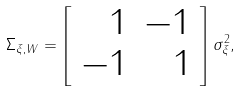<formula> <loc_0><loc_0><loc_500><loc_500>\Sigma _ { \xi , W } = \left [ \begin{array} { r r } 1 & - 1 \\ - 1 & 1 \end{array} \right ] \sigma _ { \xi } ^ { 2 } ,</formula> 